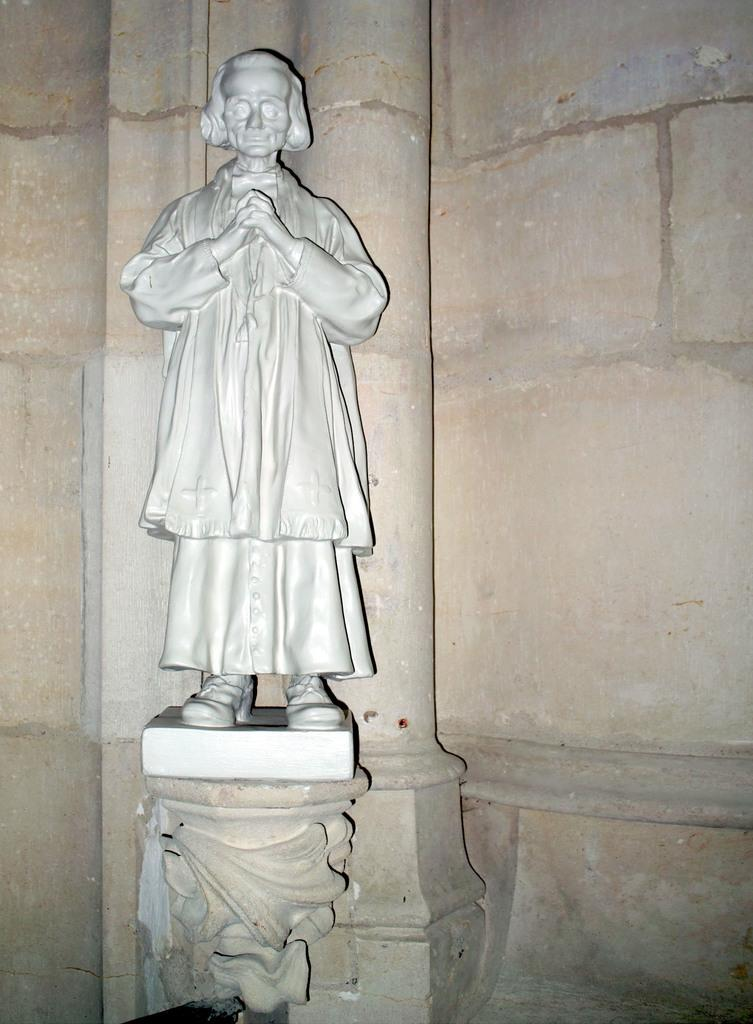What can be seen on the left side of the image? There is a sculpture on the left side of the image. What story is the sculpture telling in the image? There is no story being told by the sculpture in the image, as it is a static object and not a narrative medium. 